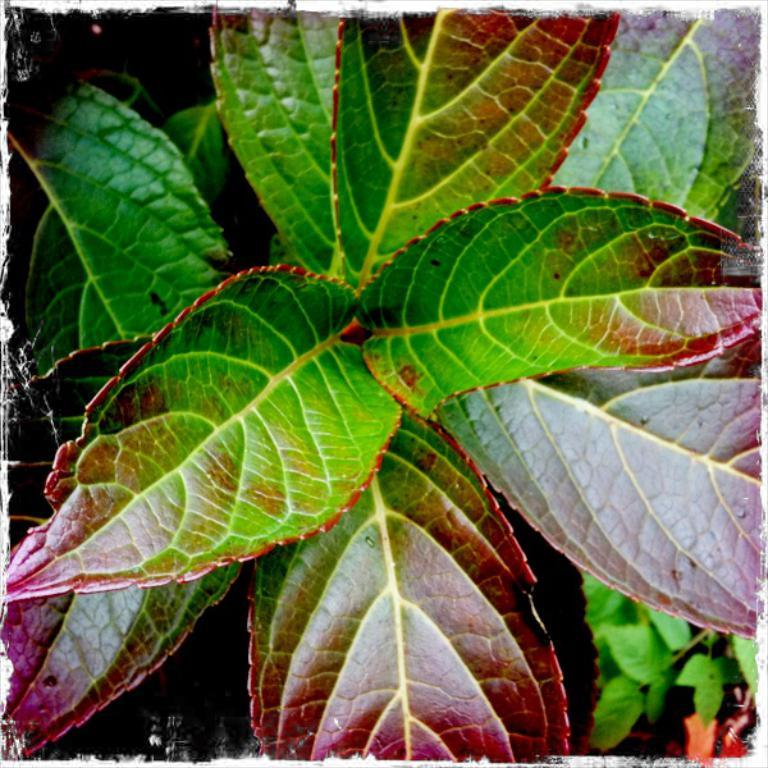What is present in the image? There is a plant in the image. What specific part of the plant can be seen? The plant has leaves. What is the name of the jewel that is hanging from the plant in the image? There is no jewel present in the image; it only features a plant with leaves. 